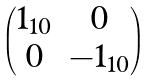<formula> <loc_0><loc_0><loc_500><loc_500>\begin{pmatrix} 1 _ { 1 0 } & 0 \\ 0 & - 1 _ { 1 0 } \end{pmatrix}</formula> 